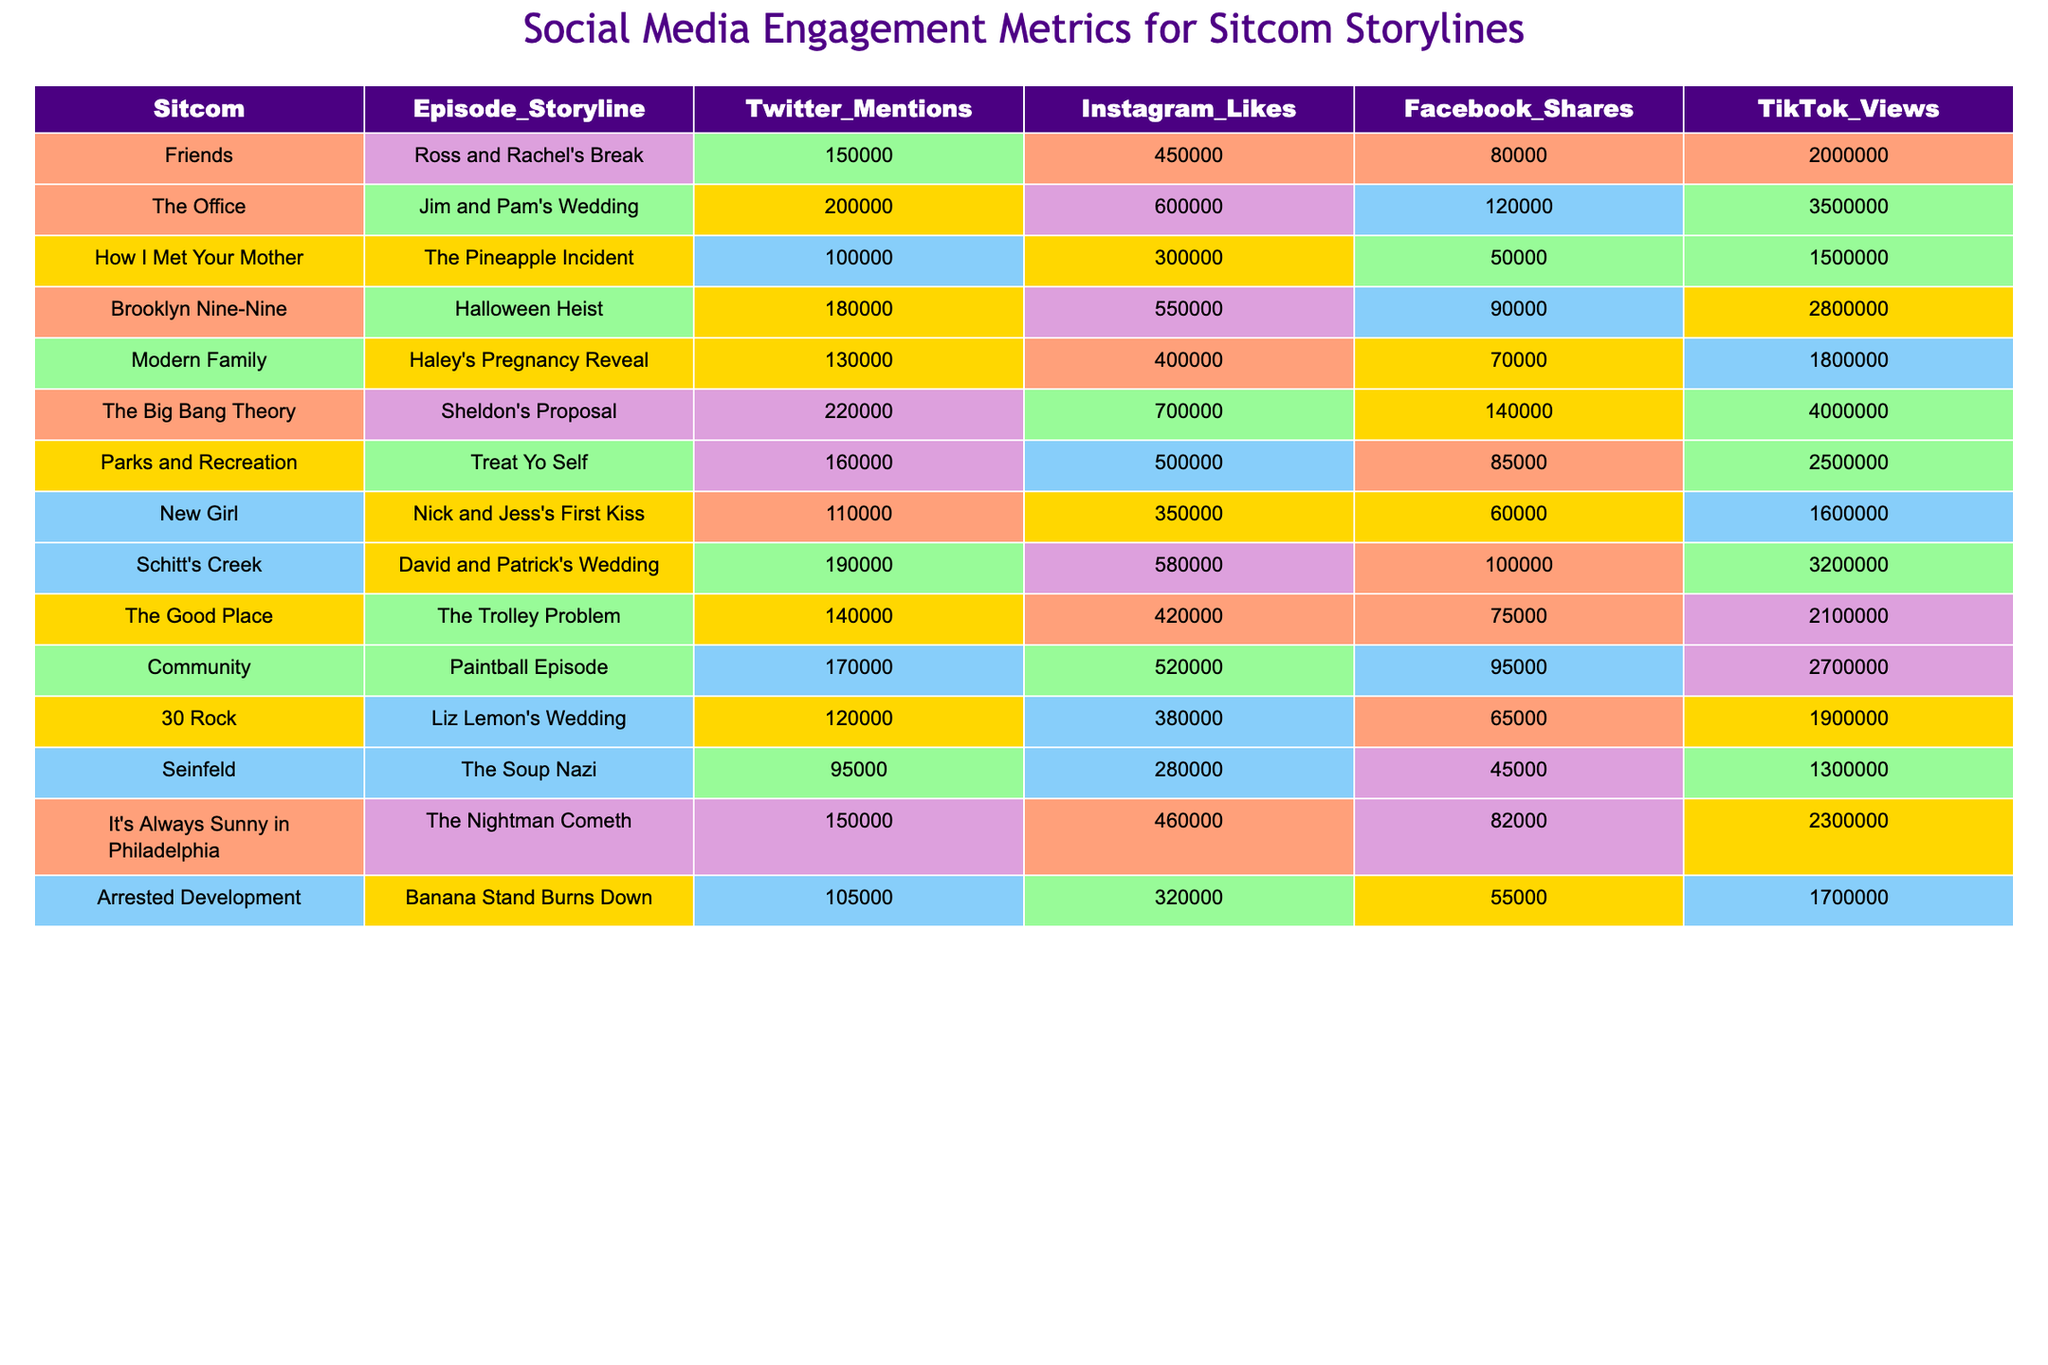What episode storyline from "The Big Bang Theory" had the most TikTok views? According to the table, the episode storyline "Sheldon's Proposal" from "The Big Bang Theory" had 4,000,000 TikTok views, which is the highest number listed.
Answer: Sheldon's Proposal Which sitcom episode received the highest number of Twitter mentions? By checking the Twitter Mentions column, "The Big Bang Theory" episode "Sheldon's Proposal" received the highest count of 220,000 Twitter mentions.
Answer: 220,000 True or False: "Jim and Pam's Wedding" had more Instagram likes than "Nick and Jess's First Kiss." The Instagram Likes for "Jim and Pam's Wedding" is 600,000 and for "Nick and Jess's First Kiss" it is 350,000. Thus, the statement is true.
Answer: True What is the average number of Facebook Shares across all the sitcom episodes? Adding the Facebook Shares: (80,000 + 120,000 + 50,000 + 90,000 + 70,000 + 140,000 + 85,000 + 60,000 + 100,000 + 75,000 + 95,000 + 65,000 + 45,000 + 82,000 + 55,000) = 1,155,000; then dividing by the number of episodes (15) gives an average of 77,000.
Answer: 77,000 Which storyline had the lowest number of Instagram likes and how many were there? Comparing the Instagram Likes column, "Seinfeld" with "The Soup Nazi" had the lowest number of likes, which amounts to 280,000.
Answer: 280,000 What is the difference in TikTok views between "How I Met Your Mother" and "Brooklyn Nine-Nine"? "How I Met Your Mother" had 1,500,000 TikTok views and "Brooklyn Nine-Nine" had 2,800,000. The difference is 2,800,000 - 1,500,000 = 1,300,000.
Answer: 1,300,000 Which sitcom episode had more combined social media engagement (sum of all metrics: Twitter Mentions + Instagram Likes + Facebook Shares + TikTok Views), "Friends" or "Parks and Recreation"? Calculating for "Friends": 150,000 + 450,000 + 80,000 + 2,000,000 = 2,680,000. For "Parks and Recreation": 160,000 + 500,000 + 85,000 + 2,500,000 = 3,245,000. Thus, "Parks and Recreation" had more combined engagement.
Answer: Parks and Recreation Which episode had the second highest engagement in TikTok views, and what was that number? After reviewing the TikTok Views column, “Schitt's Creek: David and Patrick's Wedding” had 3,200,000 views, which is the second highest after "Sheldon's Proposal."
Answer: 3,200,000 How many sitcoms had Twitter mentions greater than 150,000? Checking the Twitter Mentions column, there are six sitcoms with mentions exceeding 150,000: "The Office," "The Big Bang Theory," "Brooklyn Nine-Nine," "Friends," and "Schitt's Creek."
Answer: 6 